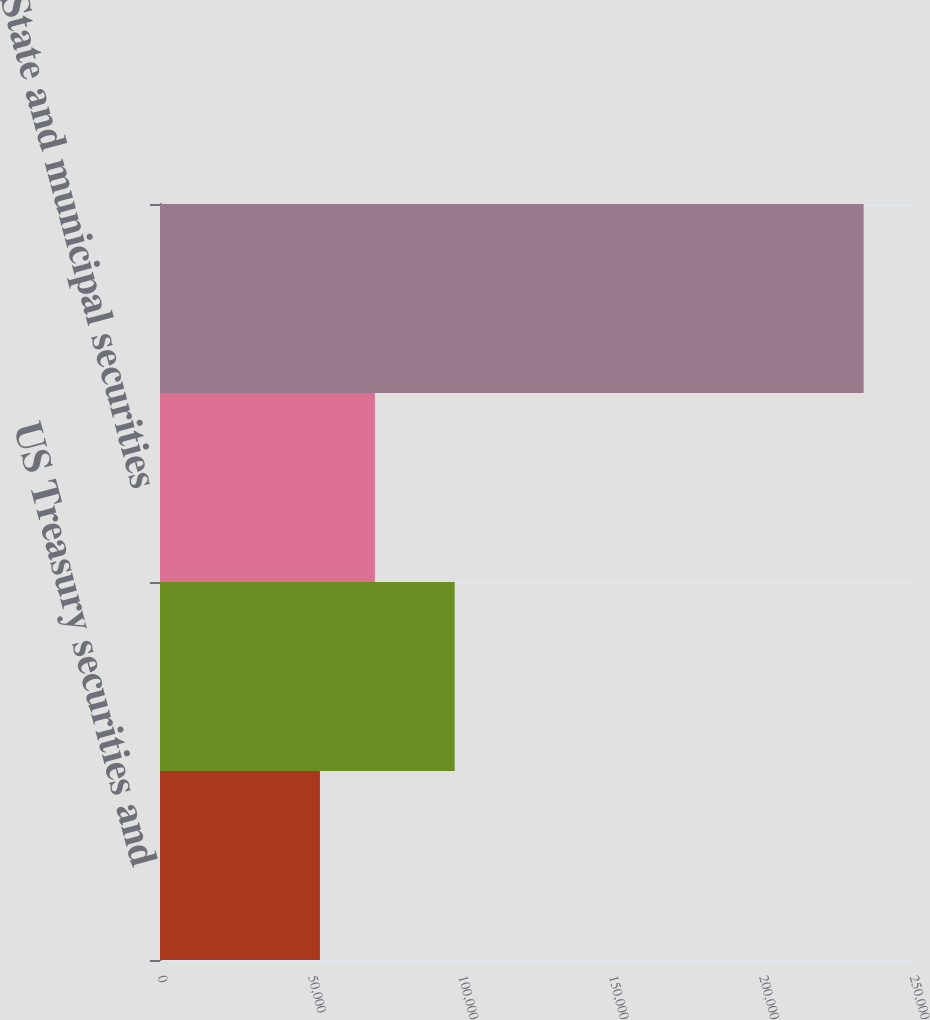Convert chart to OTSL. <chart><loc_0><loc_0><loc_500><loc_500><bar_chart><fcel>US Treasury securities and<fcel>Corporate securities<fcel>State and municipal securities<fcel>Total<nl><fcel>53171<fcel>97958<fcel>71428<fcel>233914<nl></chart> 